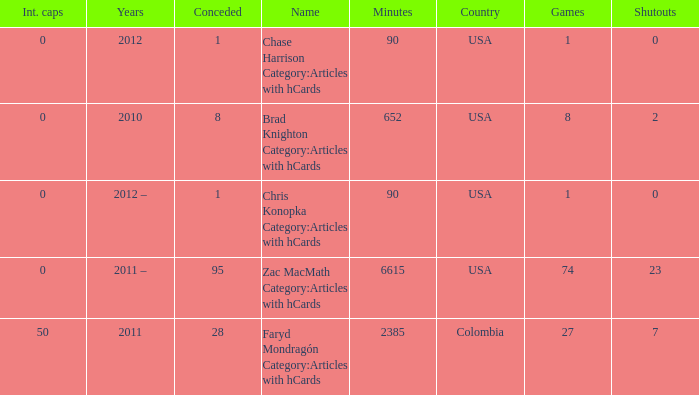When chase harrison category:articles with hcards is the name what is the year? 2012.0. 